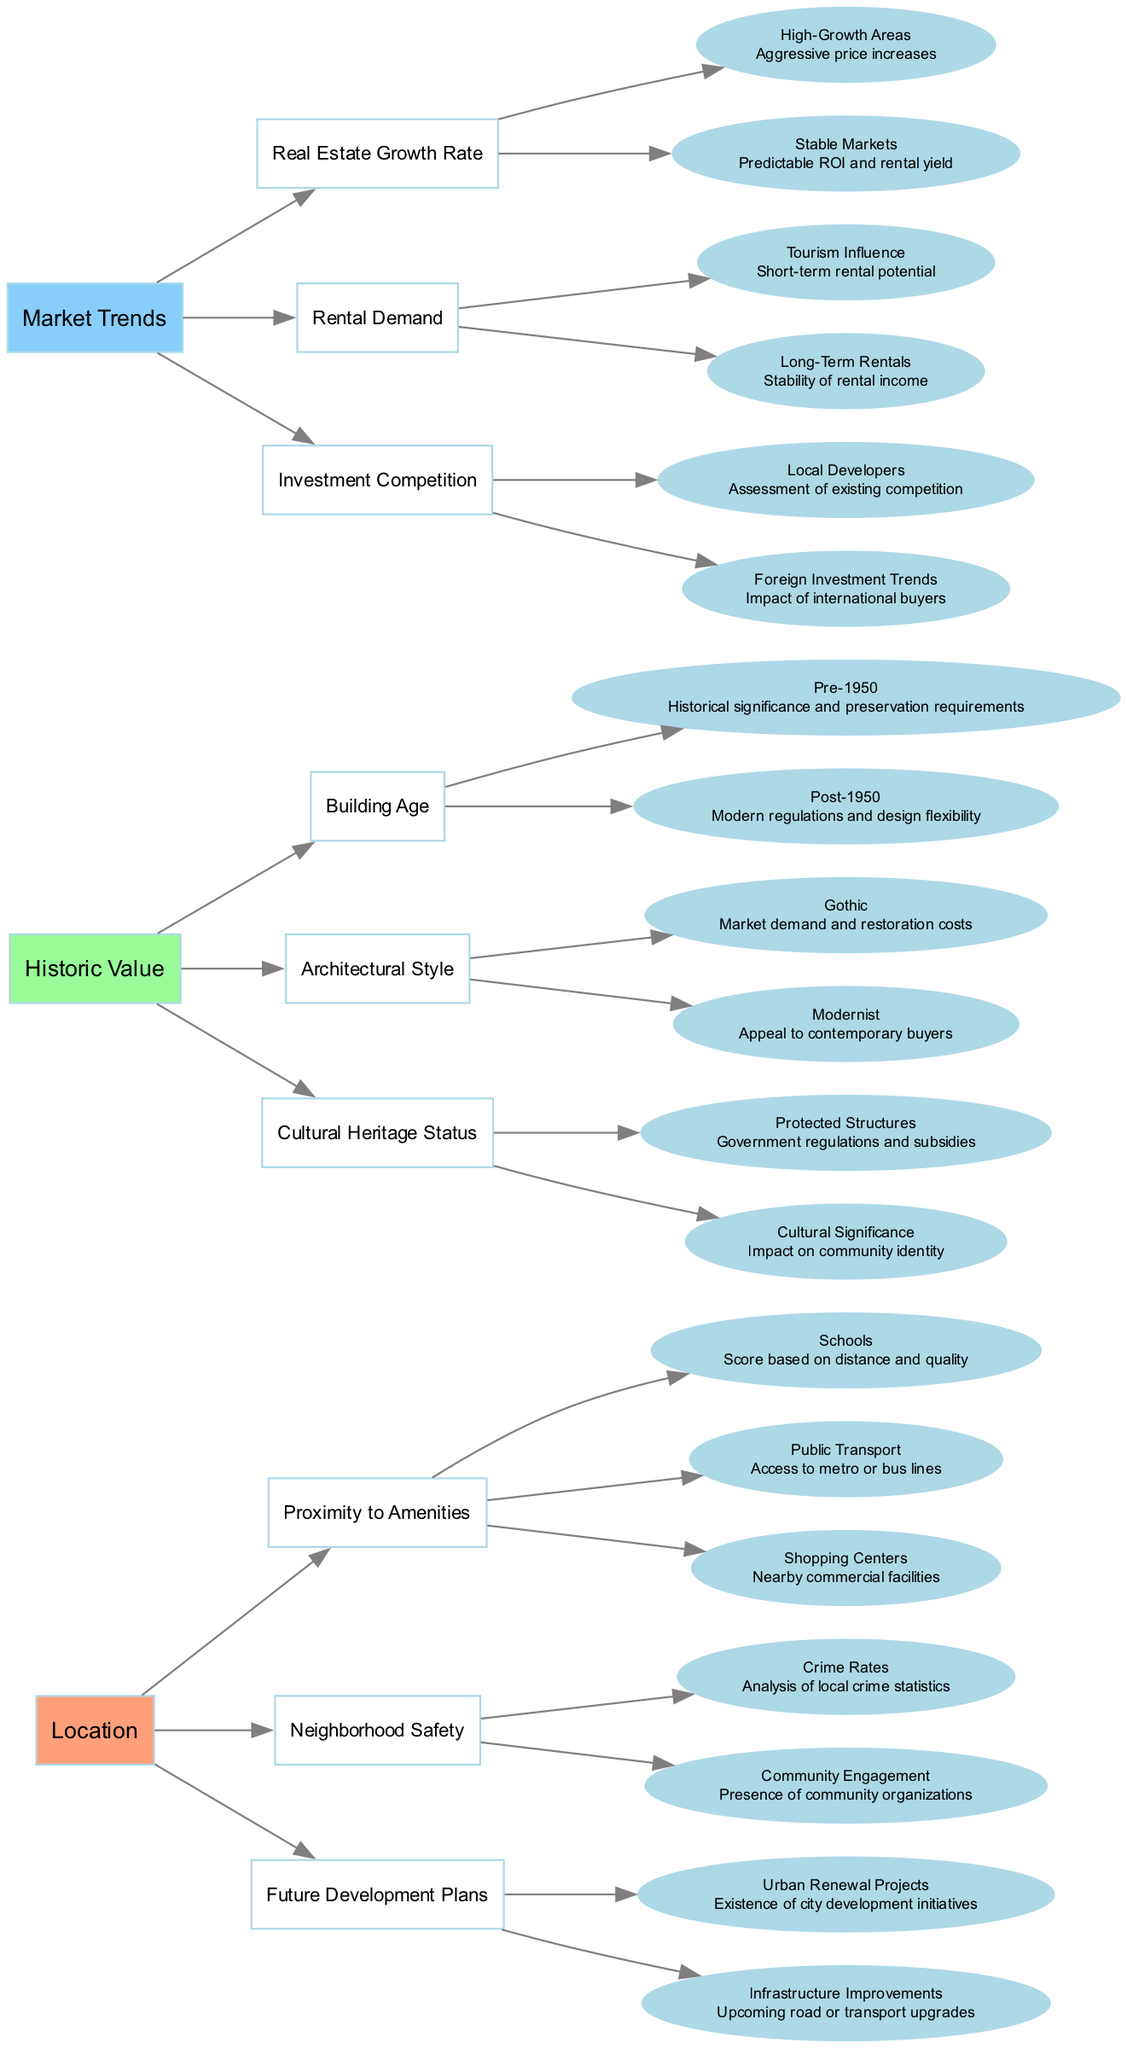What are the three main categories in the decision tree? The diagram shows three main categories: Location, Historic Value, and Market Trends. Each category is a primary node branching out into subcategories.
Answer: Location, Historic Value, Market Trends How many subcategories are under 'Historic Value'? Under the 'Historic Value' category, there are three subcategories: Building Age, Architectural Style, and Cultural Heritage Status. This can be counted directly from the branches in the diagram.
Answer: Three Which subcategory under 'Location' addresses community aspects? The 'Community Engagement' node under the 'Neighborhood Safety' subcategory addresses community aspects related to property investment. This can be determined by reviewing the nodes and their descriptions.
Answer: Community Engagement What criterion is associated with 'High-Growth Areas'? 'Aggressive price increases' is associated with the 'High-Growth Areas' criterion in the 'Real Estate Growth Rate' subcategory. This can be found directly connected in the decision tree.
Answer: Aggressive price increases Which type of building age may have historical significance? 'Pre-1950' is the building age category that indicates historical significance, based on analysis of the nodes under 'Building Age'.
Answer: Pre-1950 Which two factors are assessed under 'Investment Competition'? The two factors assessed under 'Investment Competition' are 'Local Developers' and 'Foreign Investment Trends', both shown as sub-nodes in the diagram.
Answer: Local Developers, Foreign Investment Trends How does 'Tourism Influence' affect rental demand? 'Tourism Influence' is directly related to 'Short-term rental potential', indicating that places with significant tourism have strong short-term rental demand based on the connections in the decision tree.
Answer: Short-term rental potential What relationship does 'Urban Renewal Projects' indicate for property investment? 'Urban Renewal Projects' under 'Future Development Plans' indicates the existence of city development initiatives which suggest future growth potential, inferred from the connections in the decision tree.
Answer: Existence of city development initiatives In which subcategory is 'Gothic' architectural style discussed? 'Gothic' is discussed under the 'Architectural Style' subcategory, indicating a focus on market demand and restoration costs. This can be determined by following the branches from 'Historic Value'.
Answer: Architectural Style 